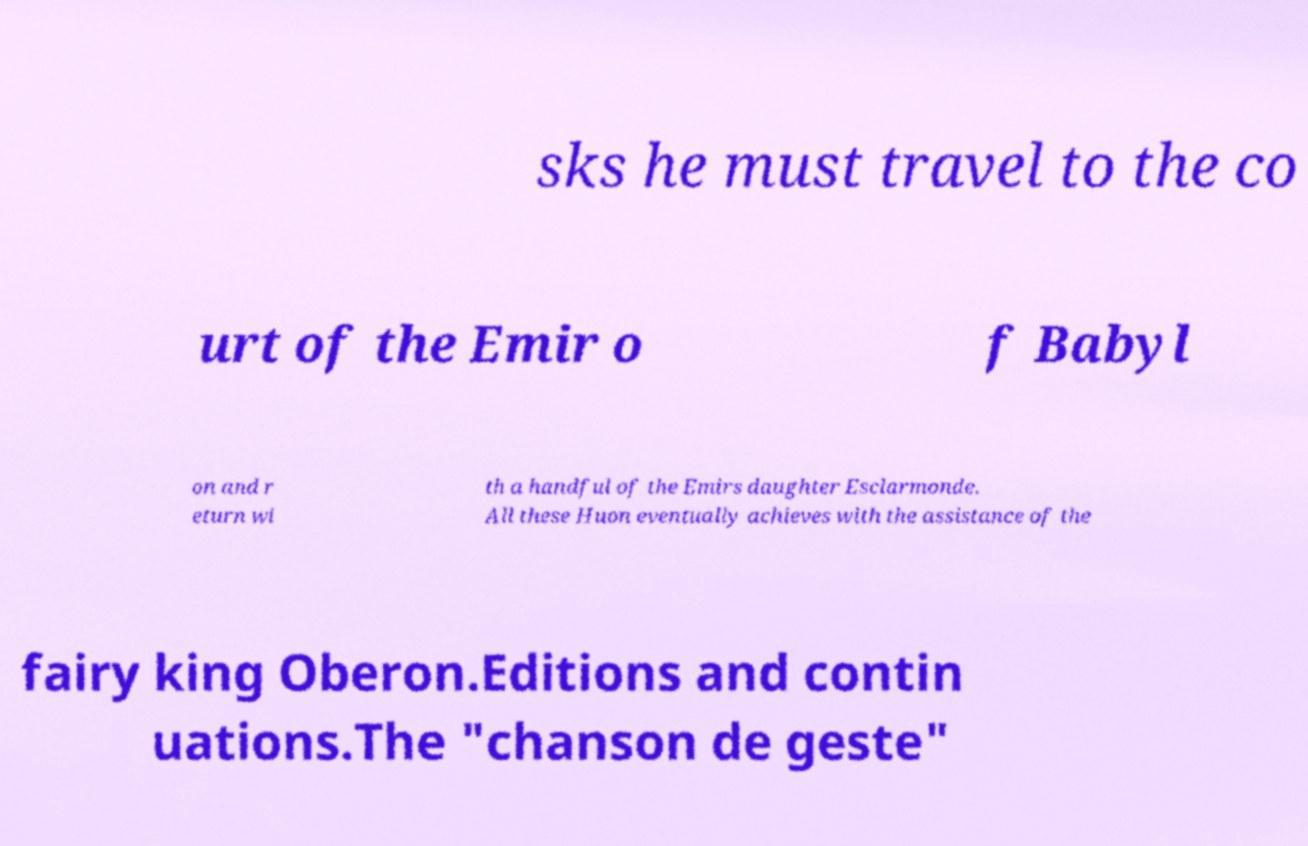Could you extract and type out the text from this image? sks he must travel to the co urt of the Emir o f Babyl on and r eturn wi th a handful of the Emirs daughter Esclarmonde. All these Huon eventually achieves with the assistance of the fairy king Oberon.Editions and contin uations.The "chanson de geste" 